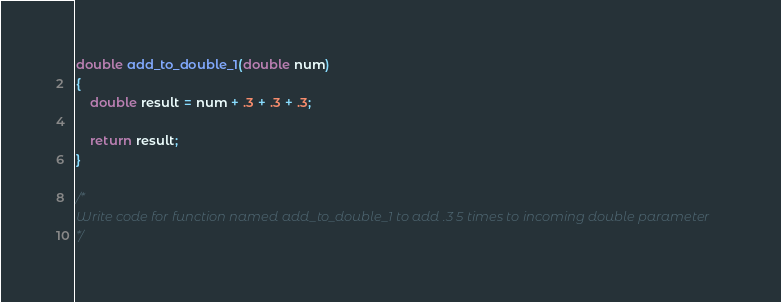Convert code to text. <code><loc_0><loc_0><loc_500><loc_500><_C++_>double add_to_double_1(double num)
{
    double result = num + .3 + .3 + .3;
    
    return result;
}

/*
Write code for function named add_to_double_1 to add .3 5 times to incoming double parameter
*/
</code> 